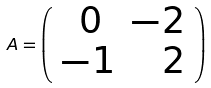<formula> <loc_0><loc_0><loc_500><loc_500>A = \left ( \begin{array} { c r c r } \, 0 & - 2 \\ - 1 & \, 2 \end{array} \right )</formula> 